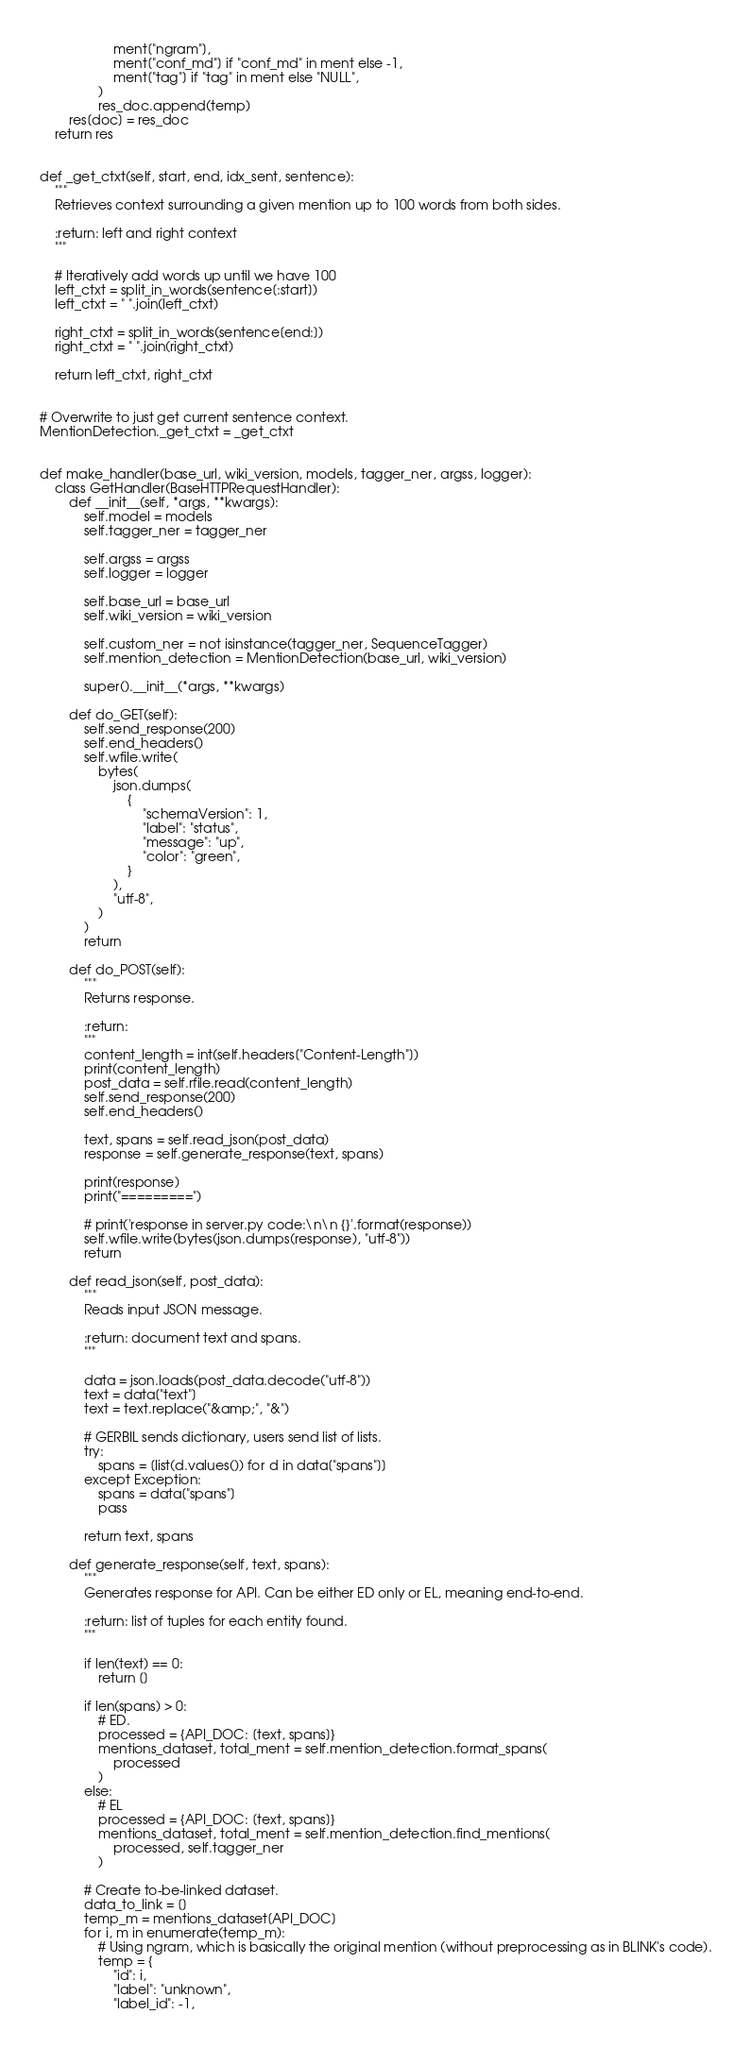Convert code to text. <code><loc_0><loc_0><loc_500><loc_500><_Python_>                    ment["ngram"],
                    ment["conf_md"] if "conf_md" in ment else -1,
                    ment["tag"] if "tag" in ment else "NULL",
                )
                res_doc.append(temp)
        res[doc] = res_doc
    return res


def _get_ctxt(self, start, end, idx_sent, sentence):
    """
    Retrieves context surrounding a given mention up to 100 words from both sides.

    :return: left and right context
    """

    # Iteratively add words up until we have 100
    left_ctxt = split_in_words(sentence[:start])
    left_ctxt = " ".join(left_ctxt)

    right_ctxt = split_in_words(sentence[end:])
    right_ctxt = " ".join(right_ctxt)

    return left_ctxt, right_ctxt


# Overwrite to just get current sentence context.
MentionDetection._get_ctxt = _get_ctxt


def make_handler(base_url, wiki_version, models, tagger_ner, argss, logger):
    class GetHandler(BaseHTTPRequestHandler):
        def __init__(self, *args, **kwargs):
            self.model = models
            self.tagger_ner = tagger_ner

            self.argss = argss
            self.logger = logger

            self.base_url = base_url
            self.wiki_version = wiki_version

            self.custom_ner = not isinstance(tagger_ner, SequenceTagger)
            self.mention_detection = MentionDetection(base_url, wiki_version)

            super().__init__(*args, **kwargs)

        def do_GET(self):
            self.send_response(200)
            self.end_headers()
            self.wfile.write(
                bytes(
                    json.dumps(
                        {
                            "schemaVersion": 1,
                            "label": "status",
                            "message": "up",
                            "color": "green",
                        }
                    ),
                    "utf-8",
                )
            )
            return

        def do_POST(self):
            """
            Returns response.

            :return:
            """
            content_length = int(self.headers["Content-Length"])
            print(content_length)
            post_data = self.rfile.read(content_length)
            self.send_response(200)
            self.end_headers()

            text, spans = self.read_json(post_data)
            response = self.generate_response(text, spans)

            print(response)
            print("=========")

            # print('response in server.py code:\n\n {}'.format(response))
            self.wfile.write(bytes(json.dumps(response), "utf-8"))
            return

        def read_json(self, post_data):
            """
            Reads input JSON message.

            :return: document text and spans.
            """

            data = json.loads(post_data.decode("utf-8"))
            text = data["text"]
            text = text.replace("&amp;", "&")

            # GERBIL sends dictionary, users send list of lists.
            try:
                spans = [list(d.values()) for d in data["spans"]]
            except Exception:
                spans = data["spans"]
                pass

            return text, spans

        def generate_response(self, text, spans):
            """
            Generates response for API. Can be either ED only or EL, meaning end-to-end.

            :return: list of tuples for each entity found.
            """

            if len(text) == 0:
                return []

            if len(spans) > 0:
                # ED.
                processed = {API_DOC: [text, spans]}
                mentions_dataset, total_ment = self.mention_detection.format_spans(
                    processed
                )
            else:
                # EL
                processed = {API_DOC: [text, spans]}
                mentions_dataset, total_ment = self.mention_detection.find_mentions(
                    processed, self.tagger_ner
                )

            # Create to-be-linked dataset.
            data_to_link = []
            temp_m = mentions_dataset[API_DOC]
            for i, m in enumerate(temp_m):
                # Using ngram, which is basically the original mention (without preprocessing as in BLINK's code).
                temp = {
                    "id": i,
                    "label": "unknown",
                    "label_id": -1,</code> 